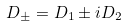<formula> <loc_0><loc_0><loc_500><loc_500>D _ { \pm } = D _ { 1 } \pm i D _ { 2 }</formula> 